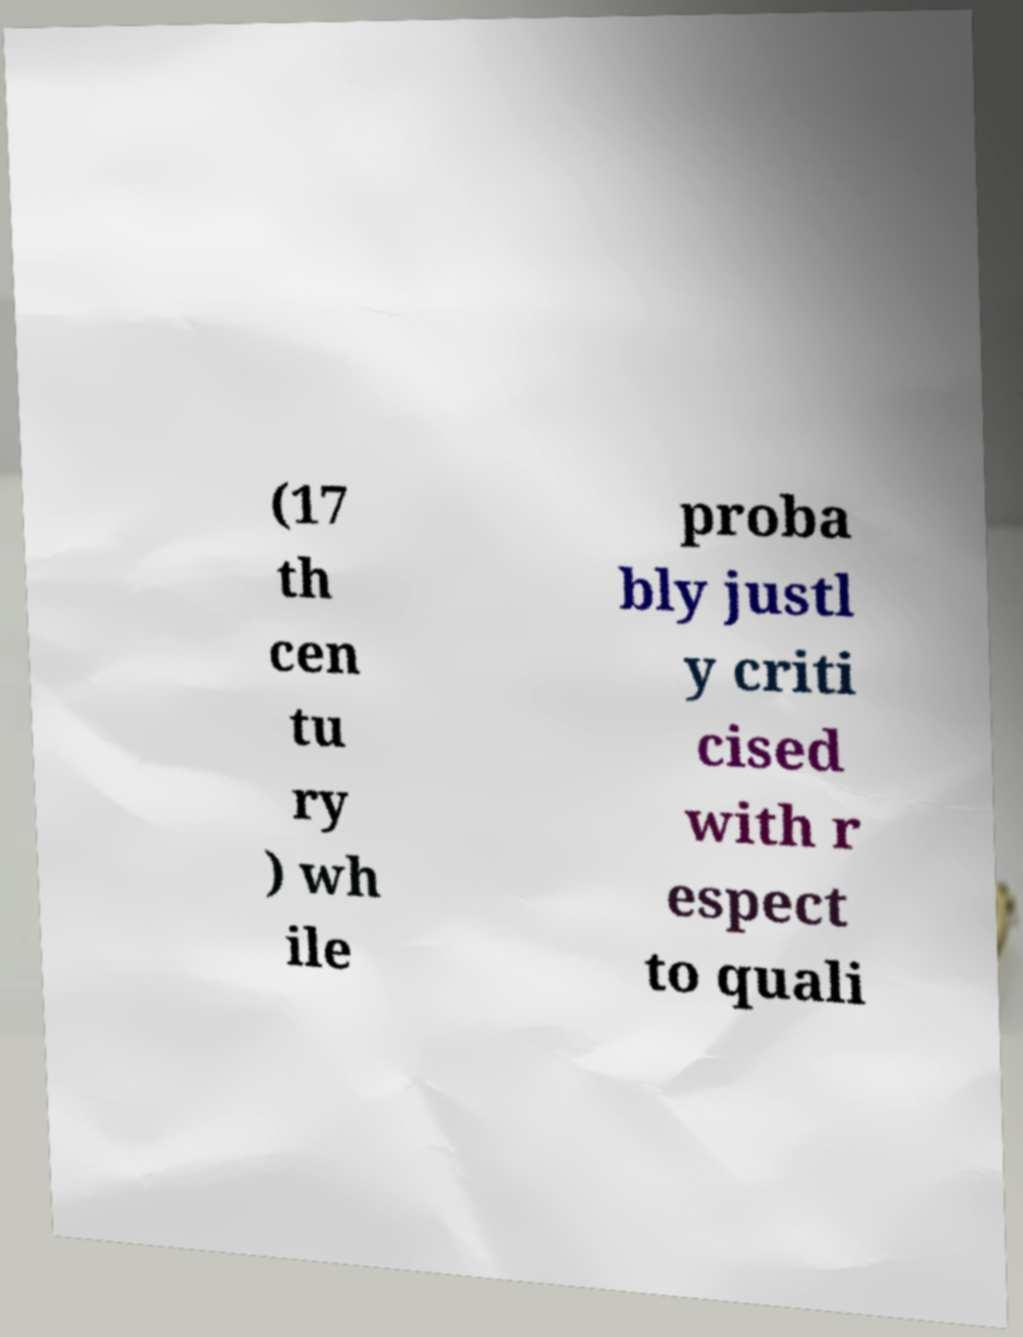Please identify and transcribe the text found in this image. (17 th cen tu ry ) wh ile proba bly justl y criti cised with r espect to quali 